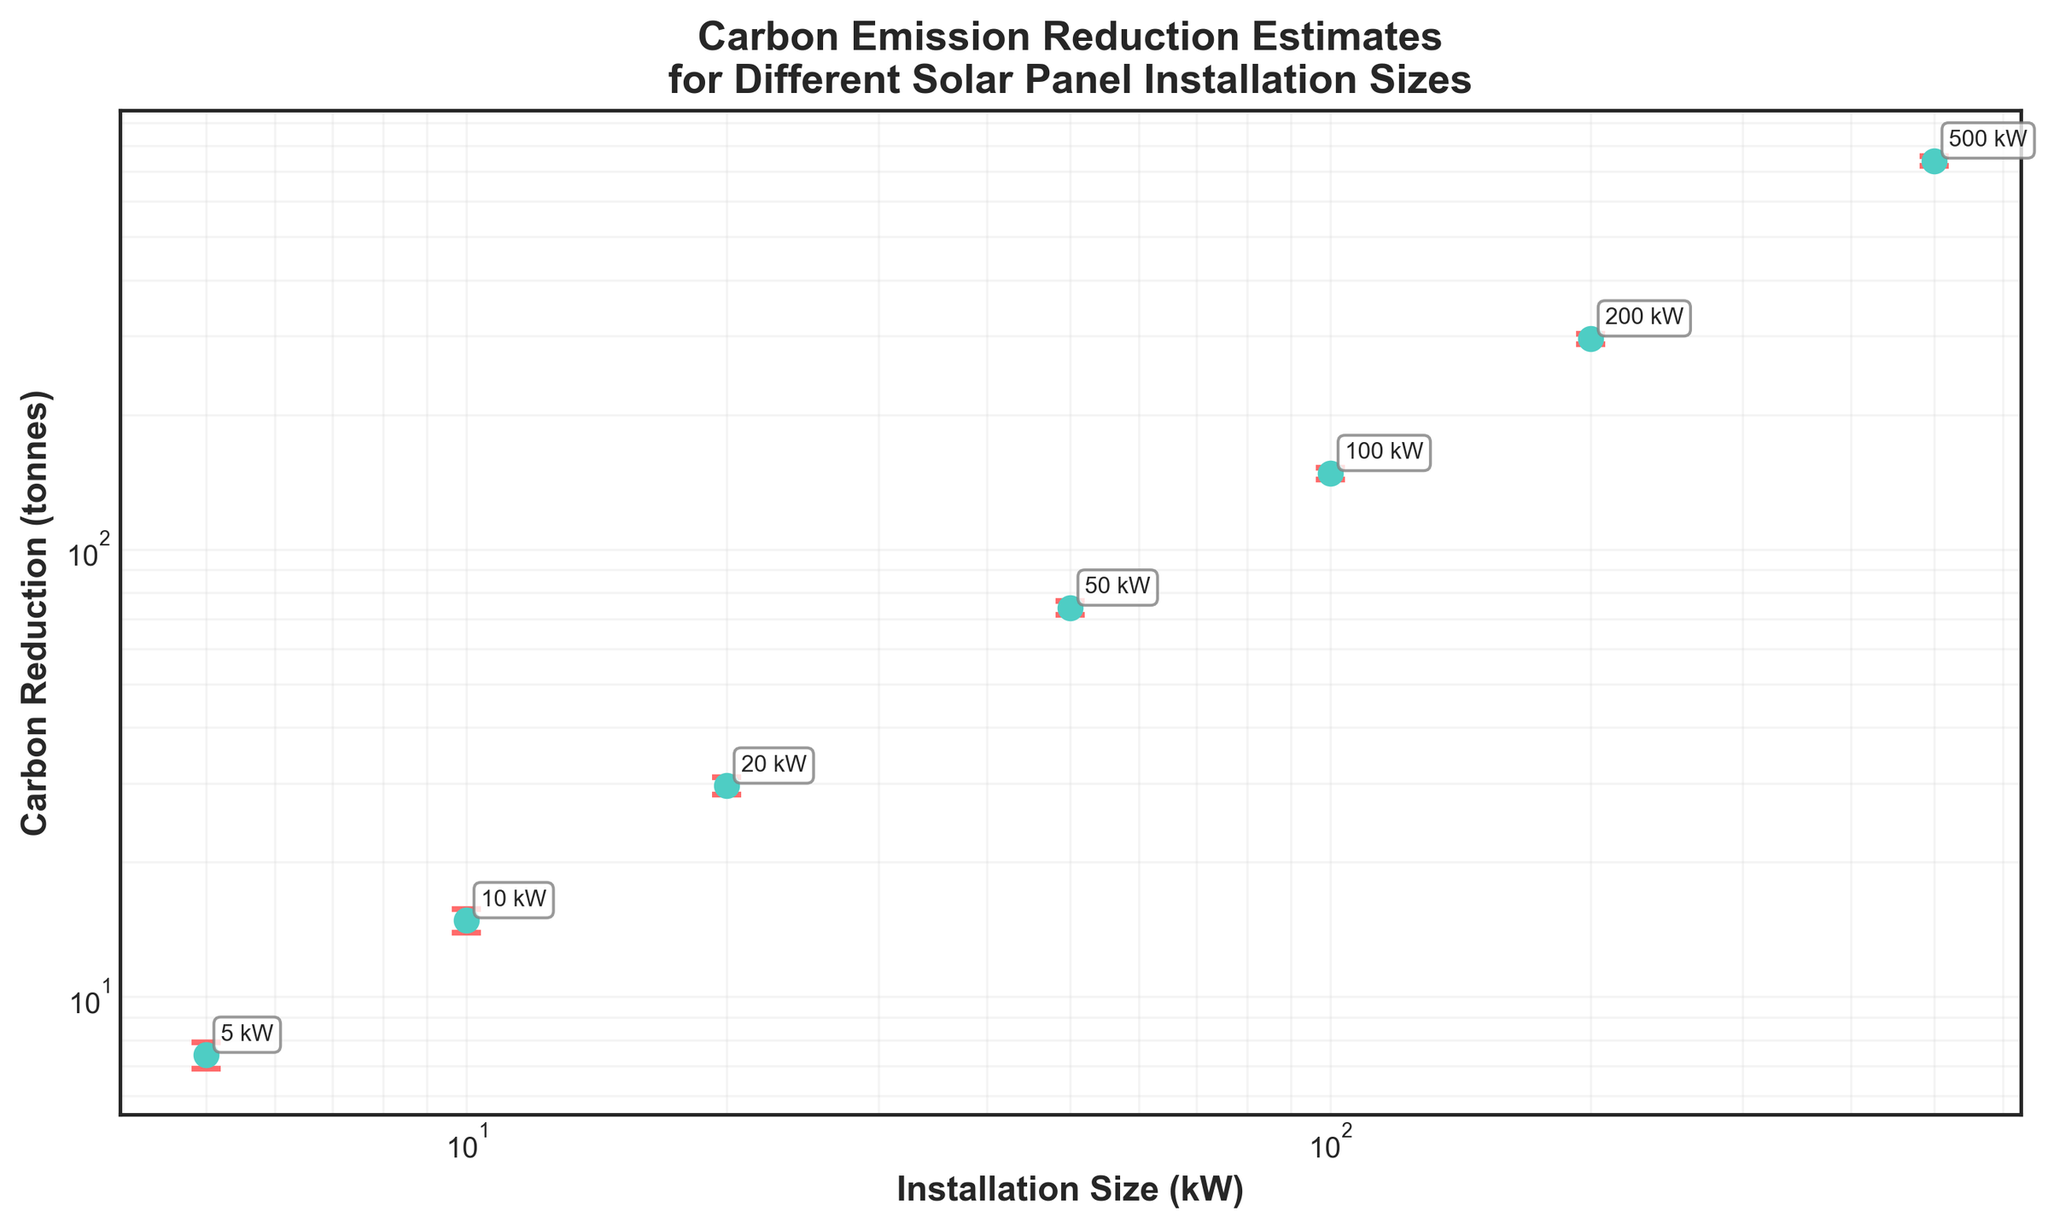what is the title of the plot? The title of the plot is located at the top of the figure. It summarizes the main subject of the plot, which is about the carbon emission reduction estimates for different solar panel installation sizes.
Answer: Carbon Emission Reduction Estimates for Different Solar Panel Installation Sizes What are the x and y axes labels? The labels of the axes provide information about what the axes represent. The x-axis label describes the variable 'Installation Size (kW)', and the y-axis label describes the variable 'Carbon Reduction (tonnes)'.
Answer: Installation Size (kW) and Carbon Reduction (tonnes) How many data points are plotted in the figure? The number of data points can be determined by counting the markers in the plot.
Answer: 7 Which installation size has the largest margin of error? To find the installation size with the largest margin of error, look for the data point with the longest error bar.
Answer: 500 kW What carbon reduction estimate is associated with a 50 kW installation size? Locate the data point corresponding to a 50 kW installation size on the x-axis and identify the y-axis value associated with it.
Answer: 74.0 tonnes What is the margin of error for a 20 kW installation size? Identify the error bar length for the data point corresponding to the 20 kW installation size. The length of the error bar indicates the margin of error.
Answer: 1.3 tonnes How does the margin of error change as the installation size increases? Observe the trend in the lengths of the error bars across the plot; they tend to increase as the installation size increases.
Answer: Increases Which two installation sizes have the closest carbon reduction estimates? Compare the y-axis values of the data points to determine which two are nearest to each other. The 10 kW and 20 kW installation sizes have estimates of 14.8 and 29.6 tonnes, respectively.
Answer: 10 kW and 20 kW By what factor does the carbon reduction estimate increase when the installation size goes from 200 kW to 500 kW? Calculate the ratio of the carbon reduction estimates for 500 kW and 200 kW installations. The estimates are 740.0 tonnes and 296.0 tonnes, respectively. The factor is 740.0 / 296.0.
Answer: 2.5 Which installation size has a margin of error corresponding to approximately 10% of its carbon reduction estimate? To find the installation size where the margin of error is about 10% of its estimate, compare the margin of error and the estimate for each data point. For the 10 kW installation, the margin of error is 0.9 tonnes, which is roughly 10% of the 14.8 tonnes estimate.
Answer: 10 kW 